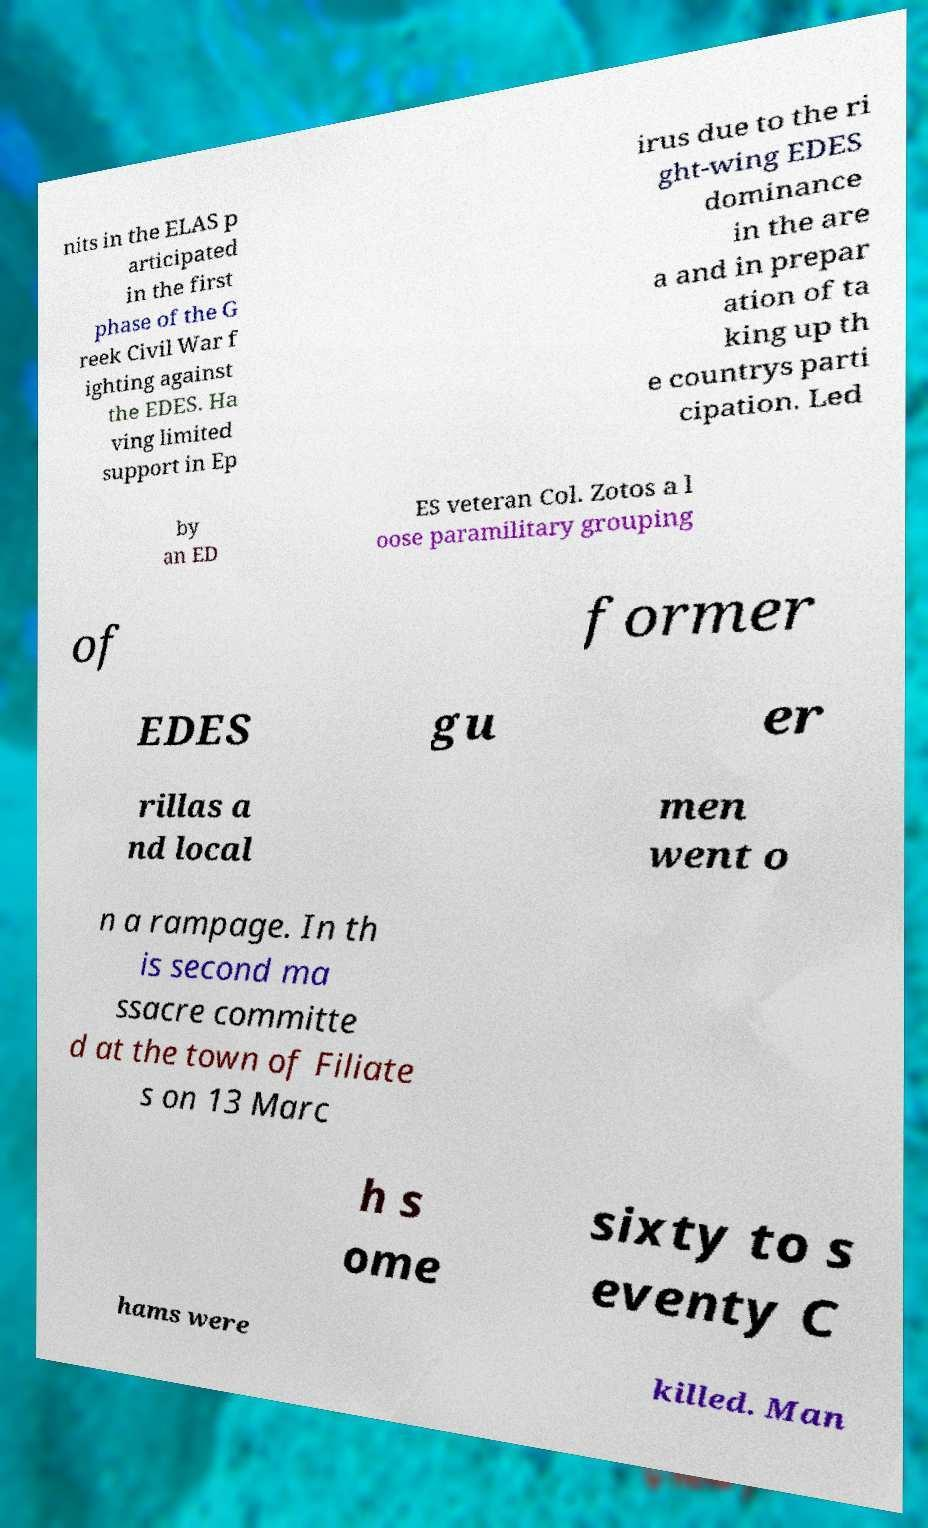Please read and relay the text visible in this image. What does it say? nits in the ELAS p articipated in the first phase of the G reek Civil War f ighting against the EDES. Ha ving limited support in Ep irus due to the ri ght-wing EDES dominance in the are a and in prepar ation of ta king up th e countrys parti cipation. Led by an ED ES veteran Col. Zotos a l oose paramilitary grouping of former EDES gu er rillas a nd local men went o n a rampage. In th is second ma ssacre committe d at the town of Filiate s on 13 Marc h s ome sixty to s eventy C hams were killed. Man 